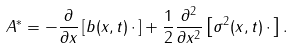Convert formula to latex. <formula><loc_0><loc_0><loc_500><loc_500>A ^ { * } = - \frac { \partial } { \partial x } \left [ b ( x , t ) \, \cdot \, \right ] + \frac { 1 } { 2 } \frac { \partial ^ { 2 } } { \partial x ^ { 2 } } \left [ \sigma ^ { 2 } ( x , t ) \, \cdot \, \right ] .</formula> 